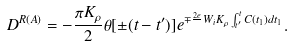Convert formula to latex. <formula><loc_0><loc_0><loc_500><loc_500>D ^ { R ( A ) } = - \frac { \pi K _ { \rho } } { 2 } \theta [ \pm ( t - t ^ { \prime } ) ] e ^ { \mp \frac { 2 e } { } W _ { i } K _ { \rho } \int ^ { t } _ { t ^ { \prime } } C ( t _ { 1 } ) d t _ { 1 } } .</formula> 